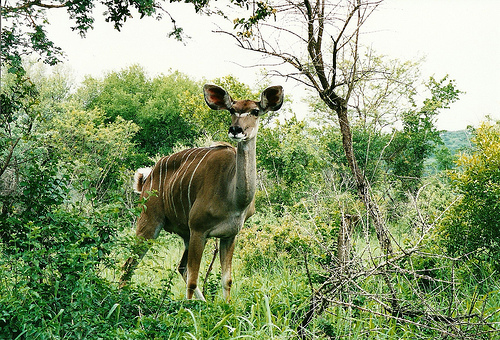<image>
Is the deer on the tree? No. The deer is not positioned on the tree. They may be near each other, but the deer is not supported by or resting on top of the tree. 